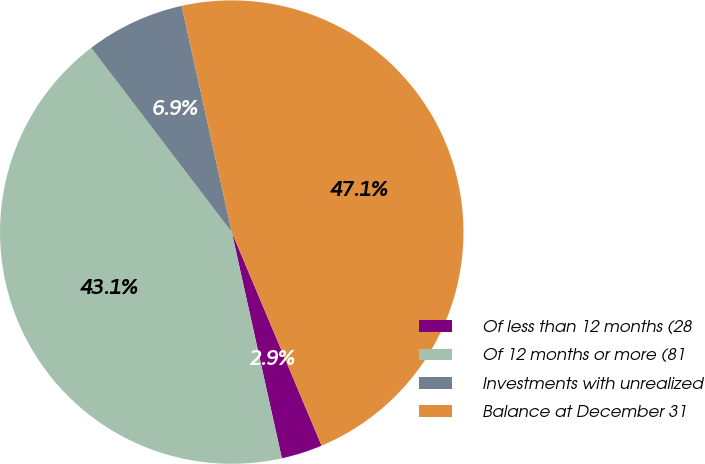Convert chart. <chart><loc_0><loc_0><loc_500><loc_500><pie_chart><fcel>Of less than 12 months (28<fcel>Of 12 months or more (81<fcel>Investments with unrealized<fcel>Balance at December 31<nl><fcel>2.87%<fcel>43.1%<fcel>6.9%<fcel>47.13%<nl></chart> 